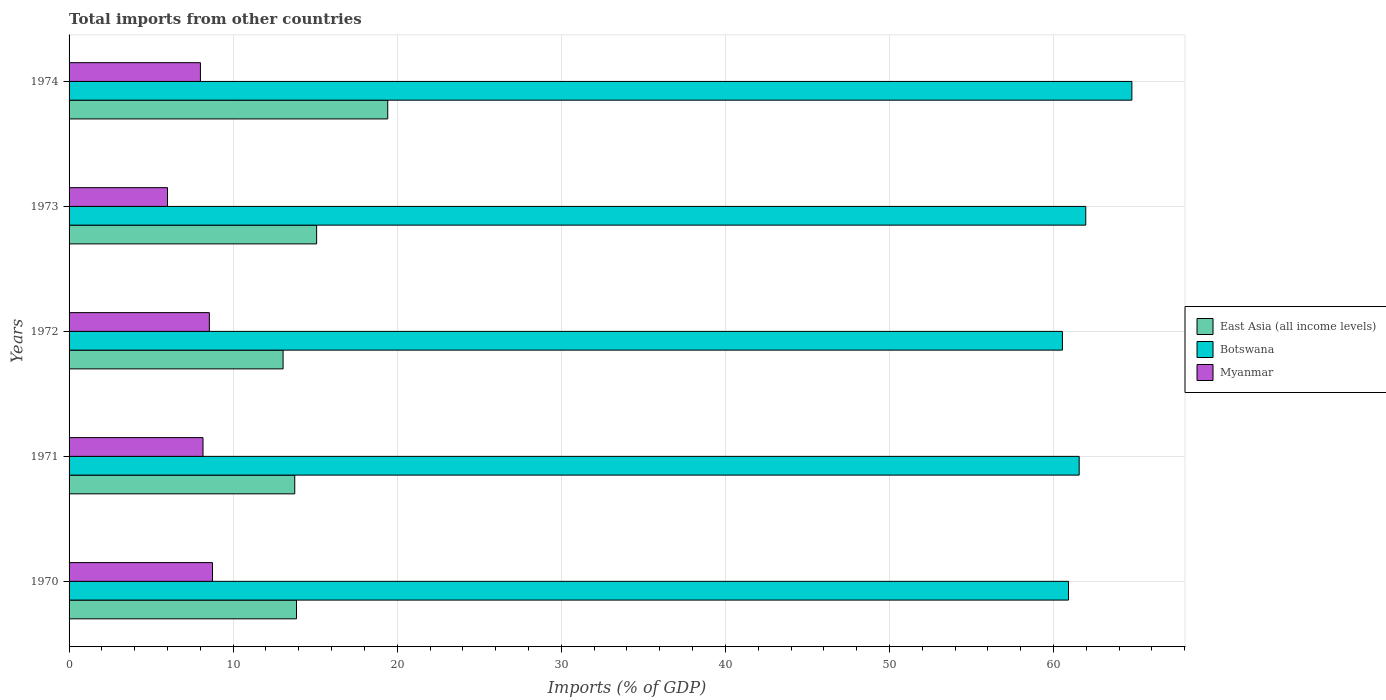Are the number of bars on each tick of the Y-axis equal?
Offer a terse response. Yes. How many bars are there on the 2nd tick from the top?
Keep it short and to the point. 3. How many bars are there on the 4th tick from the bottom?
Provide a succinct answer. 3. In how many cases, is the number of bars for a given year not equal to the number of legend labels?
Ensure brevity in your answer.  0. What is the total imports in Botswana in 1971?
Provide a short and direct response. 61.56. Across all years, what is the maximum total imports in East Asia (all income levels)?
Ensure brevity in your answer.  19.42. Across all years, what is the minimum total imports in Botswana?
Offer a very short reply. 60.54. In which year was the total imports in Botswana maximum?
Your answer should be very brief. 1974. What is the total total imports in Myanmar in the graph?
Your answer should be very brief. 39.46. What is the difference between the total imports in Myanmar in 1973 and that in 1974?
Your answer should be very brief. -2.01. What is the difference between the total imports in Botswana in 1970 and the total imports in East Asia (all income levels) in 1971?
Provide a short and direct response. 47.16. What is the average total imports in Botswana per year?
Your response must be concise. 61.95. In the year 1971, what is the difference between the total imports in Myanmar and total imports in Botswana?
Your answer should be very brief. -53.4. In how many years, is the total imports in East Asia (all income levels) greater than 10 %?
Offer a terse response. 5. What is the ratio of the total imports in East Asia (all income levels) in 1972 to that in 1974?
Provide a succinct answer. 0.67. Is the total imports in Botswana in 1971 less than that in 1974?
Your response must be concise. Yes. Is the difference between the total imports in Myanmar in 1970 and 1972 greater than the difference between the total imports in Botswana in 1970 and 1972?
Provide a short and direct response. No. What is the difference between the highest and the second highest total imports in Botswana?
Give a very brief answer. 2.81. What is the difference between the highest and the lowest total imports in Botswana?
Provide a succinct answer. 4.23. In how many years, is the total imports in Botswana greater than the average total imports in Botswana taken over all years?
Offer a very short reply. 2. What does the 1st bar from the top in 1972 represents?
Offer a very short reply. Myanmar. What does the 3rd bar from the bottom in 1974 represents?
Give a very brief answer. Myanmar. What is the difference between two consecutive major ticks on the X-axis?
Your response must be concise. 10. Does the graph contain any zero values?
Ensure brevity in your answer.  No. Where does the legend appear in the graph?
Offer a terse response. Center right. How many legend labels are there?
Provide a short and direct response. 3. What is the title of the graph?
Offer a terse response. Total imports from other countries. What is the label or title of the X-axis?
Offer a terse response. Imports (% of GDP). What is the Imports (% of GDP) of East Asia (all income levels) in 1970?
Provide a short and direct response. 13.86. What is the Imports (% of GDP) of Botswana in 1970?
Your response must be concise. 60.91. What is the Imports (% of GDP) of Myanmar in 1970?
Give a very brief answer. 8.74. What is the Imports (% of GDP) of East Asia (all income levels) in 1971?
Provide a short and direct response. 13.75. What is the Imports (% of GDP) of Botswana in 1971?
Provide a short and direct response. 61.56. What is the Imports (% of GDP) in Myanmar in 1971?
Ensure brevity in your answer.  8.16. What is the Imports (% of GDP) of East Asia (all income levels) in 1972?
Give a very brief answer. 13.04. What is the Imports (% of GDP) in Botswana in 1972?
Provide a short and direct response. 60.54. What is the Imports (% of GDP) in Myanmar in 1972?
Make the answer very short. 8.55. What is the Imports (% of GDP) of East Asia (all income levels) in 1973?
Offer a very short reply. 15.09. What is the Imports (% of GDP) of Botswana in 1973?
Give a very brief answer. 61.97. What is the Imports (% of GDP) in Myanmar in 1973?
Give a very brief answer. 6. What is the Imports (% of GDP) in East Asia (all income levels) in 1974?
Provide a short and direct response. 19.42. What is the Imports (% of GDP) of Botswana in 1974?
Your answer should be compact. 64.78. What is the Imports (% of GDP) in Myanmar in 1974?
Offer a very short reply. 8.01. Across all years, what is the maximum Imports (% of GDP) of East Asia (all income levels)?
Provide a succinct answer. 19.42. Across all years, what is the maximum Imports (% of GDP) in Botswana?
Offer a very short reply. 64.78. Across all years, what is the maximum Imports (% of GDP) in Myanmar?
Keep it short and to the point. 8.74. Across all years, what is the minimum Imports (% of GDP) in East Asia (all income levels)?
Make the answer very short. 13.04. Across all years, what is the minimum Imports (% of GDP) in Botswana?
Give a very brief answer. 60.54. Across all years, what is the minimum Imports (% of GDP) of Myanmar?
Keep it short and to the point. 6. What is the total Imports (% of GDP) in East Asia (all income levels) in the graph?
Offer a very short reply. 75.17. What is the total Imports (% of GDP) in Botswana in the graph?
Provide a succinct answer. 309.76. What is the total Imports (% of GDP) of Myanmar in the graph?
Your response must be concise. 39.46. What is the difference between the Imports (% of GDP) of East Asia (all income levels) in 1970 and that in 1971?
Your answer should be very brief. 0.11. What is the difference between the Imports (% of GDP) in Botswana in 1970 and that in 1971?
Offer a terse response. -0.65. What is the difference between the Imports (% of GDP) of Myanmar in 1970 and that in 1971?
Offer a very short reply. 0.58. What is the difference between the Imports (% of GDP) of East Asia (all income levels) in 1970 and that in 1972?
Your response must be concise. 0.82. What is the difference between the Imports (% of GDP) of Botswana in 1970 and that in 1972?
Your response must be concise. 0.37. What is the difference between the Imports (% of GDP) in Myanmar in 1970 and that in 1972?
Make the answer very short. 0.19. What is the difference between the Imports (% of GDP) in East Asia (all income levels) in 1970 and that in 1973?
Keep it short and to the point. -1.23. What is the difference between the Imports (% of GDP) in Botswana in 1970 and that in 1973?
Give a very brief answer. -1.05. What is the difference between the Imports (% of GDP) in Myanmar in 1970 and that in 1973?
Make the answer very short. 2.74. What is the difference between the Imports (% of GDP) in East Asia (all income levels) in 1970 and that in 1974?
Make the answer very short. -5.56. What is the difference between the Imports (% of GDP) in Botswana in 1970 and that in 1974?
Make the answer very short. -3.86. What is the difference between the Imports (% of GDP) of Myanmar in 1970 and that in 1974?
Offer a very short reply. 0.74. What is the difference between the Imports (% of GDP) of East Asia (all income levels) in 1971 and that in 1972?
Offer a very short reply. 0.71. What is the difference between the Imports (% of GDP) of Botswana in 1971 and that in 1972?
Give a very brief answer. 1.02. What is the difference between the Imports (% of GDP) of Myanmar in 1971 and that in 1972?
Provide a short and direct response. -0.39. What is the difference between the Imports (% of GDP) of East Asia (all income levels) in 1971 and that in 1973?
Offer a very short reply. -1.33. What is the difference between the Imports (% of GDP) of Botswana in 1971 and that in 1973?
Your response must be concise. -0.4. What is the difference between the Imports (% of GDP) of Myanmar in 1971 and that in 1973?
Give a very brief answer. 2.16. What is the difference between the Imports (% of GDP) of East Asia (all income levels) in 1971 and that in 1974?
Your answer should be compact. -5.67. What is the difference between the Imports (% of GDP) in Botswana in 1971 and that in 1974?
Provide a succinct answer. -3.21. What is the difference between the Imports (% of GDP) in Myanmar in 1971 and that in 1974?
Make the answer very short. 0.16. What is the difference between the Imports (% of GDP) in East Asia (all income levels) in 1972 and that in 1973?
Give a very brief answer. -2.04. What is the difference between the Imports (% of GDP) of Botswana in 1972 and that in 1973?
Your response must be concise. -1.42. What is the difference between the Imports (% of GDP) of Myanmar in 1972 and that in 1973?
Your response must be concise. 2.55. What is the difference between the Imports (% of GDP) in East Asia (all income levels) in 1972 and that in 1974?
Your answer should be very brief. -6.38. What is the difference between the Imports (% of GDP) in Botswana in 1972 and that in 1974?
Offer a terse response. -4.23. What is the difference between the Imports (% of GDP) of Myanmar in 1972 and that in 1974?
Offer a very short reply. 0.54. What is the difference between the Imports (% of GDP) in East Asia (all income levels) in 1973 and that in 1974?
Your response must be concise. -4.33. What is the difference between the Imports (% of GDP) in Botswana in 1973 and that in 1974?
Keep it short and to the point. -2.81. What is the difference between the Imports (% of GDP) of Myanmar in 1973 and that in 1974?
Your answer should be very brief. -2.01. What is the difference between the Imports (% of GDP) in East Asia (all income levels) in 1970 and the Imports (% of GDP) in Botswana in 1971?
Ensure brevity in your answer.  -47.7. What is the difference between the Imports (% of GDP) of East Asia (all income levels) in 1970 and the Imports (% of GDP) of Myanmar in 1971?
Your answer should be very brief. 5.7. What is the difference between the Imports (% of GDP) in Botswana in 1970 and the Imports (% of GDP) in Myanmar in 1971?
Keep it short and to the point. 52.75. What is the difference between the Imports (% of GDP) in East Asia (all income levels) in 1970 and the Imports (% of GDP) in Botswana in 1972?
Offer a very short reply. -46.68. What is the difference between the Imports (% of GDP) in East Asia (all income levels) in 1970 and the Imports (% of GDP) in Myanmar in 1972?
Ensure brevity in your answer.  5.31. What is the difference between the Imports (% of GDP) of Botswana in 1970 and the Imports (% of GDP) of Myanmar in 1972?
Your response must be concise. 52.36. What is the difference between the Imports (% of GDP) in East Asia (all income levels) in 1970 and the Imports (% of GDP) in Botswana in 1973?
Offer a terse response. -48.1. What is the difference between the Imports (% of GDP) of East Asia (all income levels) in 1970 and the Imports (% of GDP) of Myanmar in 1973?
Your answer should be compact. 7.86. What is the difference between the Imports (% of GDP) of Botswana in 1970 and the Imports (% of GDP) of Myanmar in 1973?
Keep it short and to the point. 54.91. What is the difference between the Imports (% of GDP) of East Asia (all income levels) in 1970 and the Imports (% of GDP) of Botswana in 1974?
Give a very brief answer. -50.91. What is the difference between the Imports (% of GDP) of East Asia (all income levels) in 1970 and the Imports (% of GDP) of Myanmar in 1974?
Make the answer very short. 5.86. What is the difference between the Imports (% of GDP) in Botswana in 1970 and the Imports (% of GDP) in Myanmar in 1974?
Offer a very short reply. 52.91. What is the difference between the Imports (% of GDP) in East Asia (all income levels) in 1971 and the Imports (% of GDP) in Botswana in 1972?
Offer a terse response. -46.79. What is the difference between the Imports (% of GDP) of East Asia (all income levels) in 1971 and the Imports (% of GDP) of Myanmar in 1972?
Your answer should be compact. 5.2. What is the difference between the Imports (% of GDP) in Botswana in 1971 and the Imports (% of GDP) in Myanmar in 1972?
Provide a short and direct response. 53.01. What is the difference between the Imports (% of GDP) in East Asia (all income levels) in 1971 and the Imports (% of GDP) in Botswana in 1973?
Your response must be concise. -48.21. What is the difference between the Imports (% of GDP) of East Asia (all income levels) in 1971 and the Imports (% of GDP) of Myanmar in 1973?
Provide a succinct answer. 7.76. What is the difference between the Imports (% of GDP) in Botswana in 1971 and the Imports (% of GDP) in Myanmar in 1973?
Ensure brevity in your answer.  55.56. What is the difference between the Imports (% of GDP) of East Asia (all income levels) in 1971 and the Imports (% of GDP) of Botswana in 1974?
Make the answer very short. -51.02. What is the difference between the Imports (% of GDP) of East Asia (all income levels) in 1971 and the Imports (% of GDP) of Myanmar in 1974?
Offer a terse response. 5.75. What is the difference between the Imports (% of GDP) in Botswana in 1971 and the Imports (% of GDP) in Myanmar in 1974?
Offer a terse response. 53.56. What is the difference between the Imports (% of GDP) in East Asia (all income levels) in 1972 and the Imports (% of GDP) in Botswana in 1973?
Provide a short and direct response. -48.92. What is the difference between the Imports (% of GDP) of East Asia (all income levels) in 1972 and the Imports (% of GDP) of Myanmar in 1973?
Provide a short and direct response. 7.04. What is the difference between the Imports (% of GDP) in Botswana in 1972 and the Imports (% of GDP) in Myanmar in 1973?
Your response must be concise. 54.54. What is the difference between the Imports (% of GDP) in East Asia (all income levels) in 1972 and the Imports (% of GDP) in Botswana in 1974?
Provide a short and direct response. -51.73. What is the difference between the Imports (% of GDP) of East Asia (all income levels) in 1972 and the Imports (% of GDP) of Myanmar in 1974?
Your answer should be very brief. 5.04. What is the difference between the Imports (% of GDP) in Botswana in 1972 and the Imports (% of GDP) in Myanmar in 1974?
Keep it short and to the point. 52.54. What is the difference between the Imports (% of GDP) of East Asia (all income levels) in 1973 and the Imports (% of GDP) of Botswana in 1974?
Keep it short and to the point. -49.69. What is the difference between the Imports (% of GDP) of East Asia (all income levels) in 1973 and the Imports (% of GDP) of Myanmar in 1974?
Offer a terse response. 7.08. What is the difference between the Imports (% of GDP) of Botswana in 1973 and the Imports (% of GDP) of Myanmar in 1974?
Provide a succinct answer. 53.96. What is the average Imports (% of GDP) in East Asia (all income levels) per year?
Provide a succinct answer. 15.03. What is the average Imports (% of GDP) in Botswana per year?
Your answer should be very brief. 61.95. What is the average Imports (% of GDP) in Myanmar per year?
Make the answer very short. 7.89. In the year 1970, what is the difference between the Imports (% of GDP) in East Asia (all income levels) and Imports (% of GDP) in Botswana?
Provide a short and direct response. -47.05. In the year 1970, what is the difference between the Imports (% of GDP) of East Asia (all income levels) and Imports (% of GDP) of Myanmar?
Offer a very short reply. 5.12. In the year 1970, what is the difference between the Imports (% of GDP) of Botswana and Imports (% of GDP) of Myanmar?
Offer a very short reply. 52.17. In the year 1971, what is the difference between the Imports (% of GDP) of East Asia (all income levels) and Imports (% of GDP) of Botswana?
Offer a very short reply. -47.81. In the year 1971, what is the difference between the Imports (% of GDP) of East Asia (all income levels) and Imports (% of GDP) of Myanmar?
Provide a succinct answer. 5.59. In the year 1971, what is the difference between the Imports (% of GDP) of Botswana and Imports (% of GDP) of Myanmar?
Offer a terse response. 53.4. In the year 1972, what is the difference between the Imports (% of GDP) of East Asia (all income levels) and Imports (% of GDP) of Botswana?
Give a very brief answer. -47.5. In the year 1972, what is the difference between the Imports (% of GDP) in East Asia (all income levels) and Imports (% of GDP) in Myanmar?
Provide a succinct answer. 4.49. In the year 1972, what is the difference between the Imports (% of GDP) in Botswana and Imports (% of GDP) in Myanmar?
Your answer should be compact. 51.99. In the year 1973, what is the difference between the Imports (% of GDP) in East Asia (all income levels) and Imports (% of GDP) in Botswana?
Offer a terse response. -46.88. In the year 1973, what is the difference between the Imports (% of GDP) in East Asia (all income levels) and Imports (% of GDP) in Myanmar?
Provide a short and direct response. 9.09. In the year 1973, what is the difference between the Imports (% of GDP) in Botswana and Imports (% of GDP) in Myanmar?
Provide a succinct answer. 55.97. In the year 1974, what is the difference between the Imports (% of GDP) of East Asia (all income levels) and Imports (% of GDP) of Botswana?
Offer a terse response. -45.35. In the year 1974, what is the difference between the Imports (% of GDP) in East Asia (all income levels) and Imports (% of GDP) in Myanmar?
Give a very brief answer. 11.42. In the year 1974, what is the difference between the Imports (% of GDP) of Botswana and Imports (% of GDP) of Myanmar?
Your answer should be compact. 56.77. What is the ratio of the Imports (% of GDP) in Botswana in 1970 to that in 1971?
Offer a terse response. 0.99. What is the ratio of the Imports (% of GDP) of Myanmar in 1970 to that in 1971?
Your answer should be compact. 1.07. What is the ratio of the Imports (% of GDP) in East Asia (all income levels) in 1970 to that in 1972?
Provide a short and direct response. 1.06. What is the ratio of the Imports (% of GDP) in Botswana in 1970 to that in 1972?
Offer a very short reply. 1.01. What is the ratio of the Imports (% of GDP) in Myanmar in 1970 to that in 1972?
Give a very brief answer. 1.02. What is the ratio of the Imports (% of GDP) in East Asia (all income levels) in 1970 to that in 1973?
Your answer should be very brief. 0.92. What is the ratio of the Imports (% of GDP) in Botswana in 1970 to that in 1973?
Offer a very short reply. 0.98. What is the ratio of the Imports (% of GDP) in Myanmar in 1970 to that in 1973?
Your answer should be very brief. 1.46. What is the ratio of the Imports (% of GDP) of East Asia (all income levels) in 1970 to that in 1974?
Give a very brief answer. 0.71. What is the ratio of the Imports (% of GDP) of Botswana in 1970 to that in 1974?
Your answer should be very brief. 0.94. What is the ratio of the Imports (% of GDP) of Myanmar in 1970 to that in 1974?
Ensure brevity in your answer.  1.09. What is the ratio of the Imports (% of GDP) in East Asia (all income levels) in 1971 to that in 1972?
Offer a terse response. 1.05. What is the ratio of the Imports (% of GDP) in Botswana in 1971 to that in 1972?
Your answer should be very brief. 1.02. What is the ratio of the Imports (% of GDP) of Myanmar in 1971 to that in 1972?
Your response must be concise. 0.95. What is the ratio of the Imports (% of GDP) in East Asia (all income levels) in 1971 to that in 1973?
Provide a succinct answer. 0.91. What is the ratio of the Imports (% of GDP) of Myanmar in 1971 to that in 1973?
Your answer should be very brief. 1.36. What is the ratio of the Imports (% of GDP) of East Asia (all income levels) in 1971 to that in 1974?
Provide a succinct answer. 0.71. What is the ratio of the Imports (% of GDP) in Botswana in 1971 to that in 1974?
Your answer should be very brief. 0.95. What is the ratio of the Imports (% of GDP) of Myanmar in 1971 to that in 1974?
Your answer should be compact. 1.02. What is the ratio of the Imports (% of GDP) in East Asia (all income levels) in 1972 to that in 1973?
Provide a succinct answer. 0.86. What is the ratio of the Imports (% of GDP) in Myanmar in 1972 to that in 1973?
Make the answer very short. 1.43. What is the ratio of the Imports (% of GDP) of East Asia (all income levels) in 1972 to that in 1974?
Your response must be concise. 0.67. What is the ratio of the Imports (% of GDP) of Botswana in 1972 to that in 1974?
Your response must be concise. 0.93. What is the ratio of the Imports (% of GDP) of Myanmar in 1972 to that in 1974?
Give a very brief answer. 1.07. What is the ratio of the Imports (% of GDP) of East Asia (all income levels) in 1973 to that in 1974?
Offer a terse response. 0.78. What is the ratio of the Imports (% of GDP) of Botswana in 1973 to that in 1974?
Your answer should be very brief. 0.96. What is the ratio of the Imports (% of GDP) of Myanmar in 1973 to that in 1974?
Your response must be concise. 0.75. What is the difference between the highest and the second highest Imports (% of GDP) of East Asia (all income levels)?
Ensure brevity in your answer.  4.33. What is the difference between the highest and the second highest Imports (% of GDP) in Botswana?
Give a very brief answer. 2.81. What is the difference between the highest and the second highest Imports (% of GDP) in Myanmar?
Keep it short and to the point. 0.19. What is the difference between the highest and the lowest Imports (% of GDP) in East Asia (all income levels)?
Keep it short and to the point. 6.38. What is the difference between the highest and the lowest Imports (% of GDP) of Botswana?
Your answer should be very brief. 4.23. What is the difference between the highest and the lowest Imports (% of GDP) of Myanmar?
Make the answer very short. 2.74. 